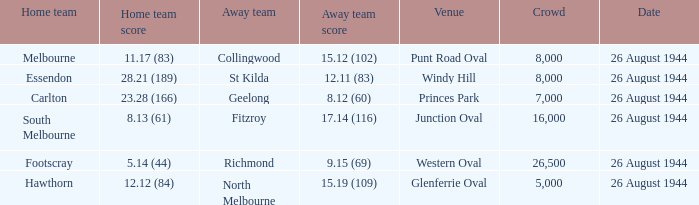What's the average crowd size when the Home team is melbourne? 8000.0. 